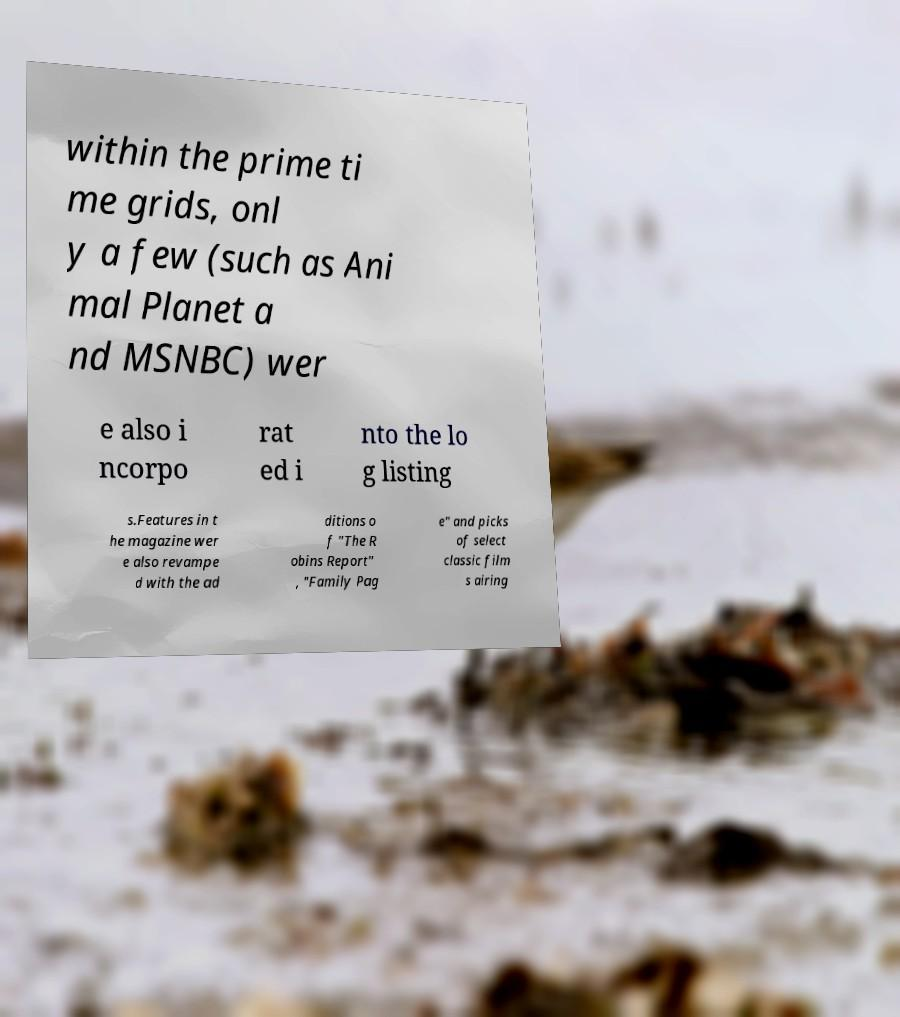Could you extract and type out the text from this image? within the prime ti me grids, onl y a few (such as Ani mal Planet a nd MSNBC) wer e also i ncorpo rat ed i nto the lo g listing s.Features in t he magazine wer e also revampe d with the ad ditions o f "The R obins Report" , "Family Pag e" and picks of select classic film s airing 